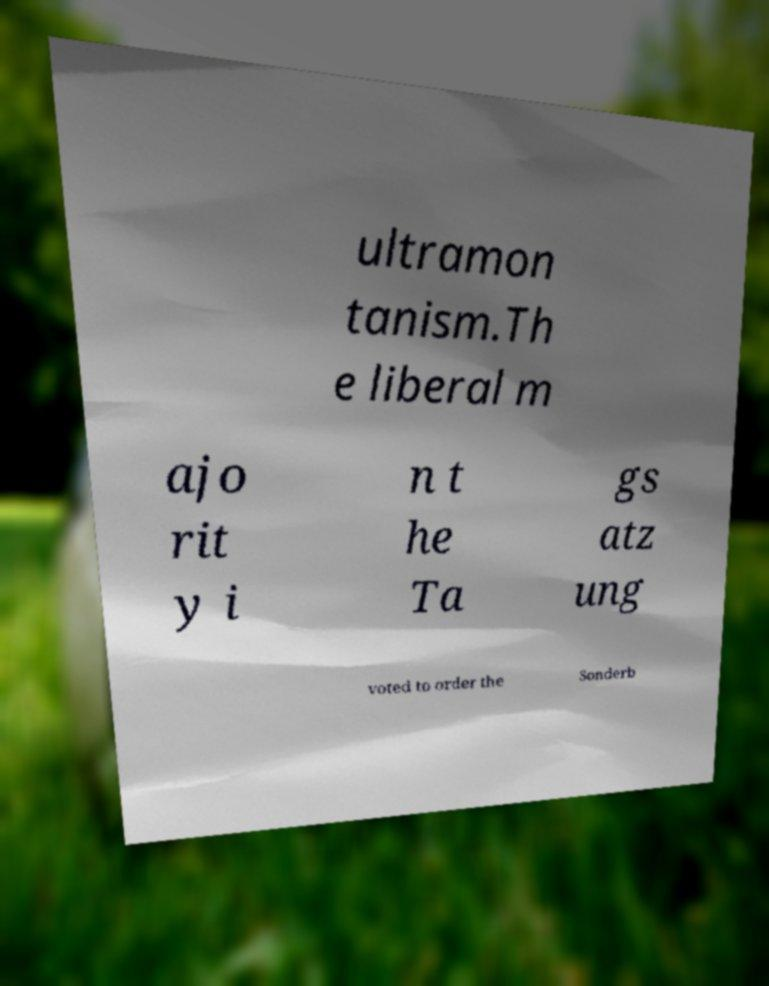Please read and relay the text visible in this image. What does it say? ultramon tanism.Th e liberal m ajo rit y i n t he Ta gs atz ung voted to order the Sonderb 